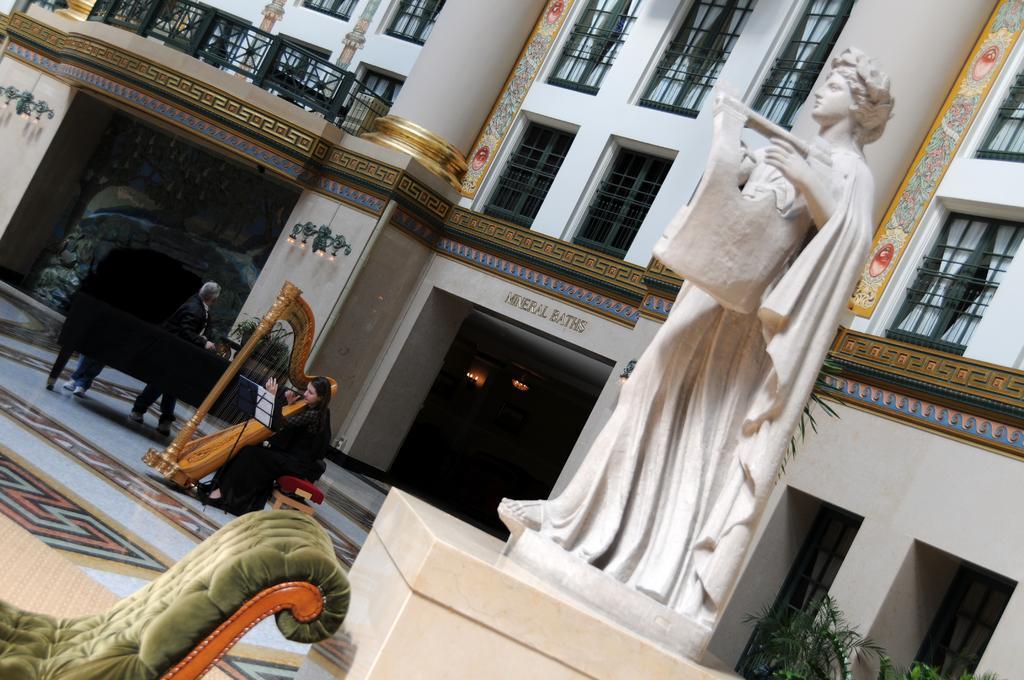Could you give a brief overview of what you see in this image? In this image we can see a building and it is having many windows. There is a statue in the image. There are few lights in the image. We can see a person playing a musical instrument in the image. There are few people in the image. There is some text on the wall. There are few plants at the right side of the image. 